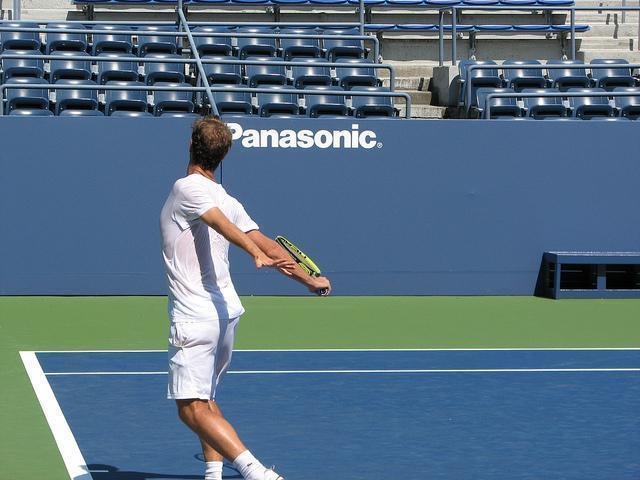How many people are in the photo?
Give a very brief answer. 1. How many benches are in the picture?
Give a very brief answer. 1. How many black umbrella are there?
Give a very brief answer. 0. 